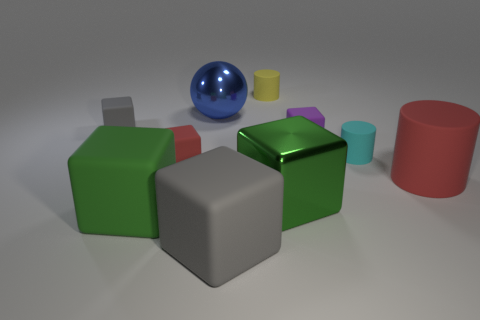Can you describe the size and colors of the objects that are in front of the gray cube? In front of the gray cube, there're several objects of various sizes and colors. Starting from the left, there's a small red matte cube, a small yellow matte cylinder, and a small blue glossy sphere. These items display a palette of primary colors and are distinct not just in their hues but also in their shapes and finishes.  Are there any objects with a reflective surface, and if so, which ones? Yes, within the image several objects exhibit a reflective surface. Most notably, the large blue sphere seems to have a glossy, reflective finish, which allows the light and environment to be partially mirrored on its surface. Additionally, the green cube on the right-hand side also seems to have a reflective surface, indicated by the specular highlights and the distinguishable gleam on its edges. 